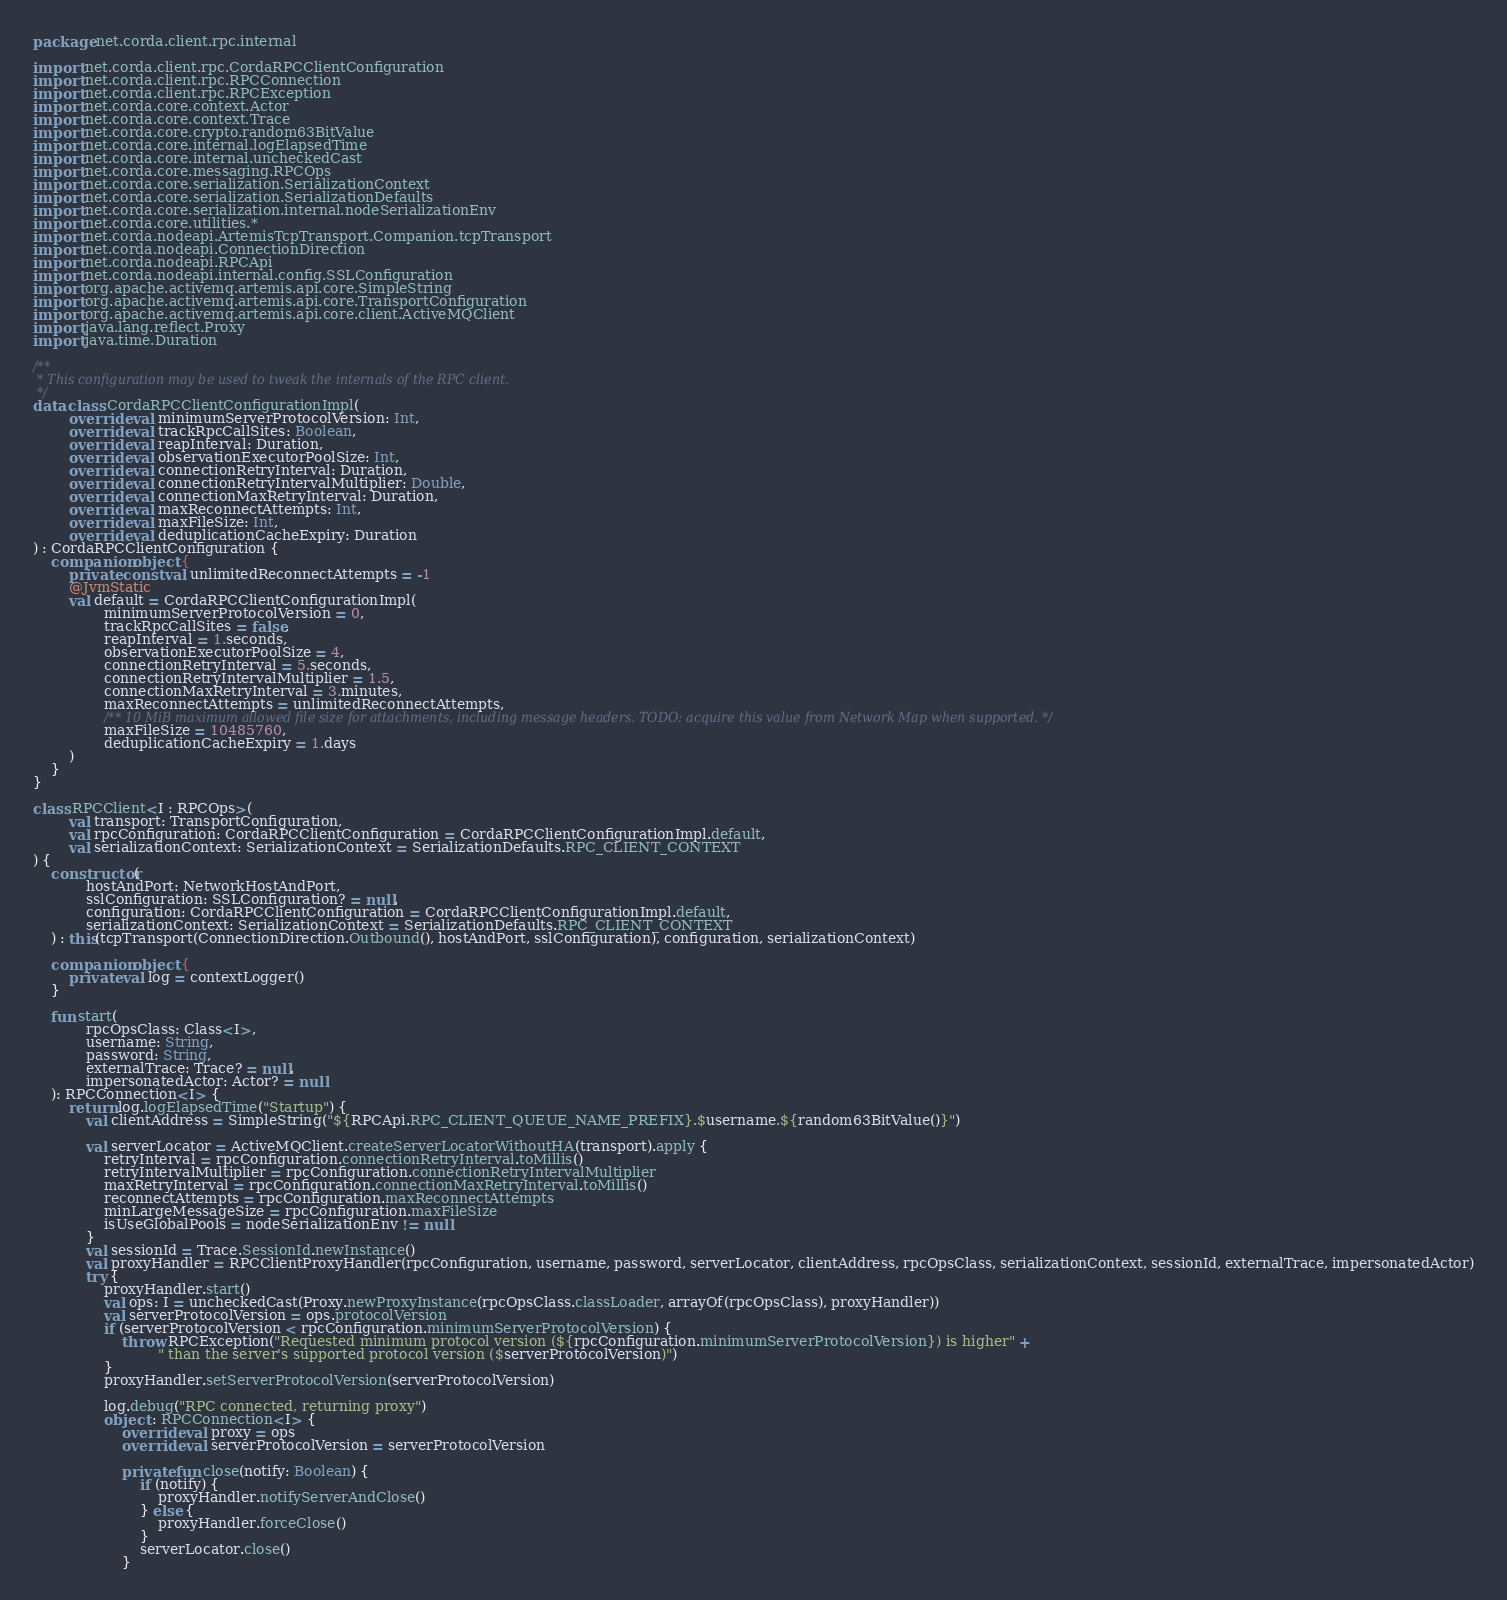<code> <loc_0><loc_0><loc_500><loc_500><_Kotlin_>package net.corda.client.rpc.internal

import net.corda.client.rpc.CordaRPCClientConfiguration
import net.corda.client.rpc.RPCConnection
import net.corda.client.rpc.RPCException
import net.corda.core.context.Actor
import net.corda.core.context.Trace
import net.corda.core.crypto.random63BitValue
import net.corda.core.internal.logElapsedTime
import net.corda.core.internal.uncheckedCast
import net.corda.core.messaging.RPCOps
import net.corda.core.serialization.SerializationContext
import net.corda.core.serialization.SerializationDefaults
import net.corda.core.serialization.internal.nodeSerializationEnv
import net.corda.core.utilities.*
import net.corda.nodeapi.ArtemisTcpTransport.Companion.tcpTransport
import net.corda.nodeapi.ConnectionDirection
import net.corda.nodeapi.RPCApi
import net.corda.nodeapi.internal.config.SSLConfiguration
import org.apache.activemq.artemis.api.core.SimpleString
import org.apache.activemq.artemis.api.core.TransportConfiguration
import org.apache.activemq.artemis.api.core.client.ActiveMQClient
import java.lang.reflect.Proxy
import java.time.Duration

/**
 * This configuration may be used to tweak the internals of the RPC client.
 */
data class CordaRPCClientConfigurationImpl(
        override val minimumServerProtocolVersion: Int,
        override val trackRpcCallSites: Boolean,
        override val reapInterval: Duration,
        override val observationExecutorPoolSize: Int,
        override val connectionRetryInterval: Duration,
        override val connectionRetryIntervalMultiplier: Double,
        override val connectionMaxRetryInterval: Duration,
        override val maxReconnectAttempts: Int,
        override val maxFileSize: Int,
        override val deduplicationCacheExpiry: Duration
) : CordaRPCClientConfiguration {
    companion object {
        private const val unlimitedReconnectAttempts = -1
        @JvmStatic
        val default = CordaRPCClientConfigurationImpl(
                minimumServerProtocolVersion = 0,
                trackRpcCallSites = false,
                reapInterval = 1.seconds,
                observationExecutorPoolSize = 4,
                connectionRetryInterval = 5.seconds,
                connectionRetryIntervalMultiplier = 1.5,
                connectionMaxRetryInterval = 3.minutes,
                maxReconnectAttempts = unlimitedReconnectAttempts,
                /** 10 MiB maximum allowed file size for attachments, including message headers. TODO: acquire this value from Network Map when supported. */
                maxFileSize = 10485760,
                deduplicationCacheExpiry = 1.days
        )
    }
}

class RPCClient<I : RPCOps>(
        val transport: TransportConfiguration,
        val rpcConfiguration: CordaRPCClientConfiguration = CordaRPCClientConfigurationImpl.default,
        val serializationContext: SerializationContext = SerializationDefaults.RPC_CLIENT_CONTEXT
) {
    constructor(
            hostAndPort: NetworkHostAndPort,
            sslConfiguration: SSLConfiguration? = null,
            configuration: CordaRPCClientConfiguration = CordaRPCClientConfigurationImpl.default,
            serializationContext: SerializationContext = SerializationDefaults.RPC_CLIENT_CONTEXT
    ) : this(tcpTransport(ConnectionDirection.Outbound(), hostAndPort, sslConfiguration), configuration, serializationContext)

    companion object {
        private val log = contextLogger()
    }

    fun start(
            rpcOpsClass: Class<I>,
            username: String,
            password: String,
            externalTrace: Trace? = null,
            impersonatedActor: Actor? = null
    ): RPCConnection<I> {
        return log.logElapsedTime("Startup") {
            val clientAddress = SimpleString("${RPCApi.RPC_CLIENT_QUEUE_NAME_PREFIX}.$username.${random63BitValue()}")

            val serverLocator = ActiveMQClient.createServerLocatorWithoutHA(transport).apply {
                retryInterval = rpcConfiguration.connectionRetryInterval.toMillis()
                retryIntervalMultiplier = rpcConfiguration.connectionRetryIntervalMultiplier
                maxRetryInterval = rpcConfiguration.connectionMaxRetryInterval.toMillis()
                reconnectAttempts = rpcConfiguration.maxReconnectAttempts
                minLargeMessageSize = rpcConfiguration.maxFileSize
                isUseGlobalPools = nodeSerializationEnv != null
            }
            val sessionId = Trace.SessionId.newInstance()
            val proxyHandler = RPCClientProxyHandler(rpcConfiguration, username, password, serverLocator, clientAddress, rpcOpsClass, serializationContext, sessionId, externalTrace, impersonatedActor)
            try {
                proxyHandler.start()
                val ops: I = uncheckedCast(Proxy.newProxyInstance(rpcOpsClass.classLoader, arrayOf(rpcOpsClass), proxyHandler))
                val serverProtocolVersion = ops.protocolVersion
                if (serverProtocolVersion < rpcConfiguration.minimumServerProtocolVersion) {
                    throw RPCException("Requested minimum protocol version (${rpcConfiguration.minimumServerProtocolVersion}) is higher" +
                            " than the server's supported protocol version ($serverProtocolVersion)")
                }
                proxyHandler.setServerProtocolVersion(serverProtocolVersion)

                log.debug("RPC connected, returning proxy")
                object : RPCConnection<I> {
                    override val proxy = ops
                    override val serverProtocolVersion = serverProtocolVersion

                    private fun close(notify: Boolean) {
                        if (notify) {
                            proxyHandler.notifyServerAndClose()
                        } else {
                            proxyHandler.forceClose()
                        }
                        serverLocator.close()
                    }
</code> 